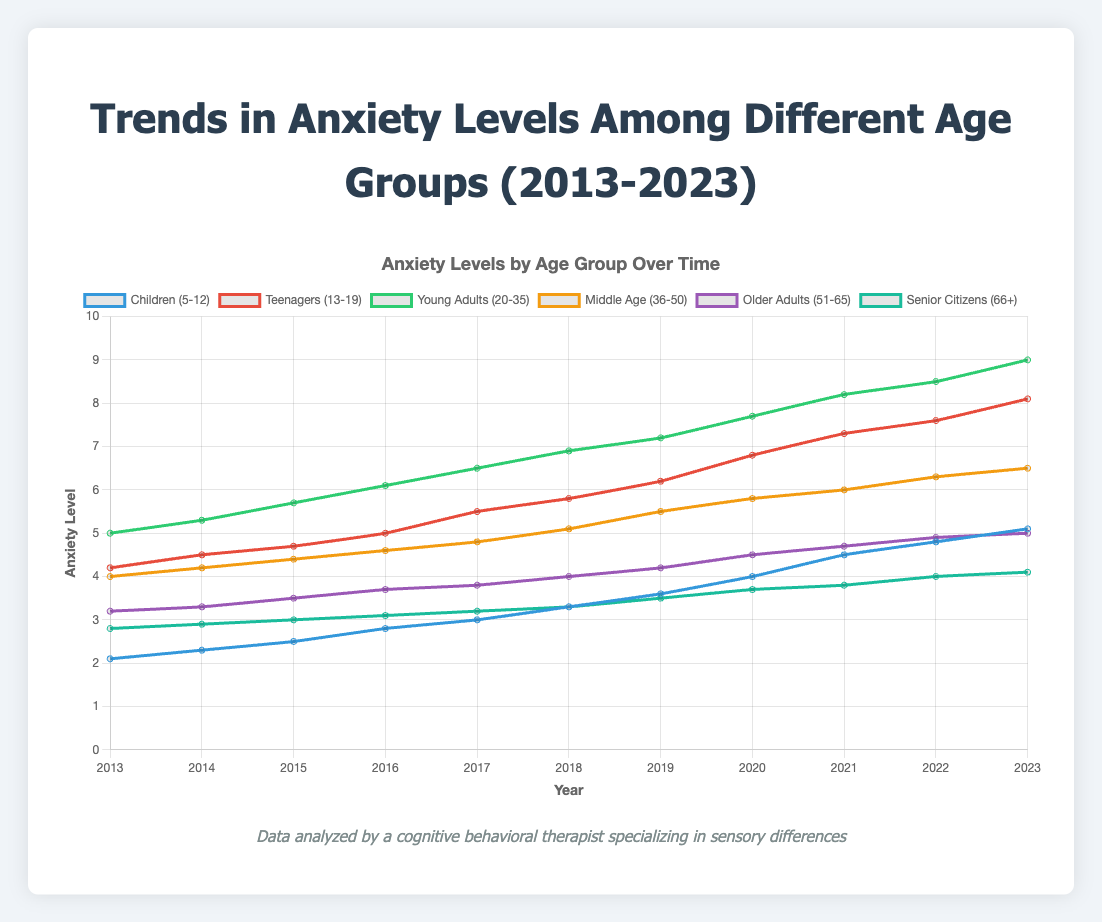What's the trend in anxiety levels for the "Children (5-12)" group from 2013 to 2023? To find the trend, observe the line representing the "Children (5-12)" group from 2013 to 2023. Starting at 2.1 in 2013, the values steadily increase each year, reaching 5.1 in 2023. This shows an increasing trend in anxiety levels.
Answer: Increasing Which age group had the highest anxiety levels in 2023? Look at the values for each age group in the year 2023. The "Young Adults (20-35)" group has the highest anxiety level with a value of 9.0.
Answer: Young Adults (20-35) What is the average anxiety level for "Teenagers (13-19)" across the decade? To calculate the average, sum up the anxiety levels for "Teenagers (13-19)" from 2013 to 2023 (4.2 + 4.5 + 4.7 + 5.0 + 5.5 + 5.8 + 6.2 + 6.8 + 7.3 + 7.6 + 8.1) = 65.7. Divide by the number of years, 65.7 / 11 ≈ 5.97.
Answer: 5.97 By how much did the anxiety level for "Middle Age (36-50)" increase from 2013 to 2023? Find the difference between the anxiety levels in 2023 and 2013 for the "Middle Age (36-50)" group. In 2023, it is 6.5, and in 2013, it was 4.0. The increase is 6.5 - 4.0 = 2.5.
Answer: 2.5 Which age group showed the least change in anxiety levels over the decade and what’s the change? Calculate the change for each age group by subtracting the 2013 value from the 2023 value. The "Senior Citizens (66+)" group shows the least change: 4.1 - 2.8 = 1.3.
Answer: Senior Citizens (66+), 1.3 Between which years did the "Older Adults (51-65)" group experience the largest increase in anxiety levels? Compare the year-to-year changes for the "Older Adults (51-65)" group: identify the years with the largest difference between consecutive years. The largest increase occurred between 2017 (3.8) and 2018 (4.0), a change of 0.2.
Answer: 2017 to 2018 Which age group surpasses the "Middle Age (36-50)" group in anxiety levels and in what year did it happen? Compare the "Middle Age (36-50)" group's levels with each other group's levels for each year. The "Young Adults (20-35)" group always had higher anxiety levels, while "Teenagers (13-19)" surpassed them in 2016 (5.0 vs. 4.6).
Answer: Teenagers (13-19), 2016 What is the total increase in anxiety levels for "Children (5-12)" and "Older Adults (51-65)" over the decade? For "Children (5-12)", the increase is 5.1 - 2.1 = 3.0. For "Older Adults (51-65)", the increase is 5.0 - 3.2 = 1.8. The total increase is 3.0 + 1.8 = 4.8.
Answer: 4.8 What visual attribute helps differentiate the anxiety levels among different age groups in the chart? The chart uses different colored lines for each age group, making it easy to see and differentiate between the anxiety levels of each group over time.
Answer: Different colored lines In which year did the anxiety levels of "Teenagers (13-19)" reach or exceed the starting anxiety level of "Young Adults (20-35)"? Look for the year when "Teenagers (13-19)" anxiety level (4.2 in 2013) meets or exceeds the "Young Adults (20-35)" starting level (5.0 in 2013). This happens in 2020 when the "Teenagers (13-19)" anxiety level reaches 6.8.
Answer: 2020 